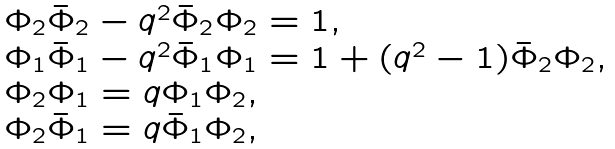Convert formula to latex. <formula><loc_0><loc_0><loc_500><loc_500>\begin{array} { l } { { \Phi _ { 2 } \bar { \Phi } _ { 2 } - q ^ { 2 } \bar { \Phi } _ { 2 } \Phi _ { 2 } = 1 , } } \\ { { \Phi _ { 1 } \bar { \Phi } _ { 1 } - q ^ { 2 } \bar { \Phi } _ { 1 } \Phi _ { 1 } = 1 + ( q ^ { 2 } - 1 ) \bar { \Phi } _ { 2 } \Phi _ { 2 } , } } \\ { { \Phi _ { 2 } \Phi _ { 1 } = q \Phi _ { 1 } \Phi _ { 2 } , } } \\ { { \Phi _ { 2 } \bar { \Phi } _ { 1 } = q \bar { \Phi } _ { 1 } \Phi _ { 2 } , } } \end{array}</formula> 